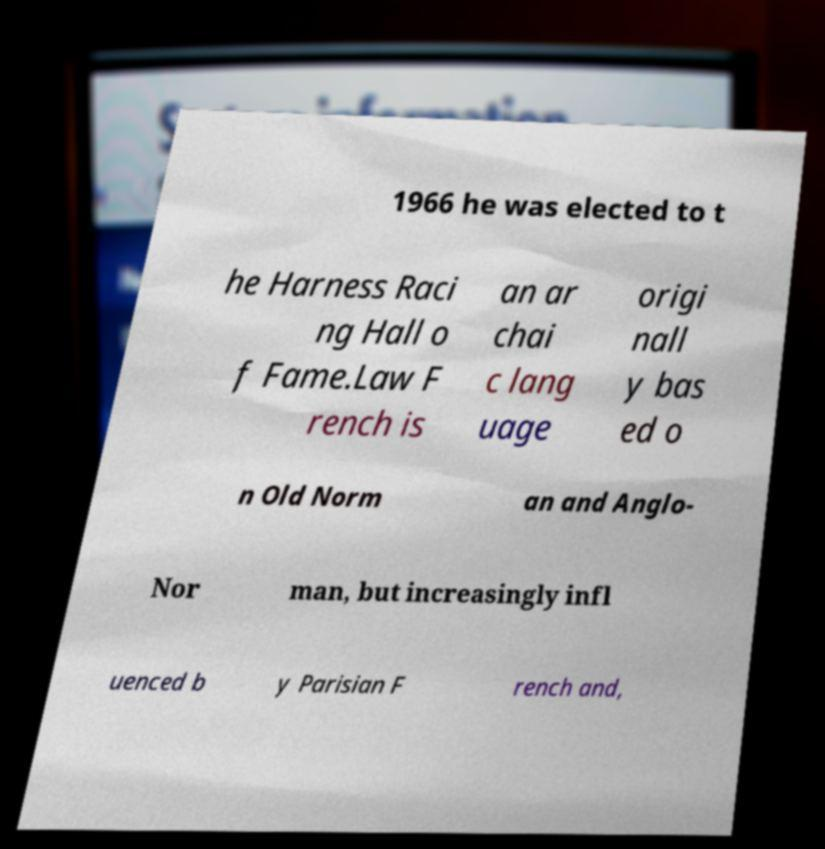Please identify and transcribe the text found in this image. 1966 he was elected to t he Harness Raci ng Hall o f Fame.Law F rench is an ar chai c lang uage origi nall y bas ed o n Old Norm an and Anglo- Nor man, but increasingly infl uenced b y Parisian F rench and, 